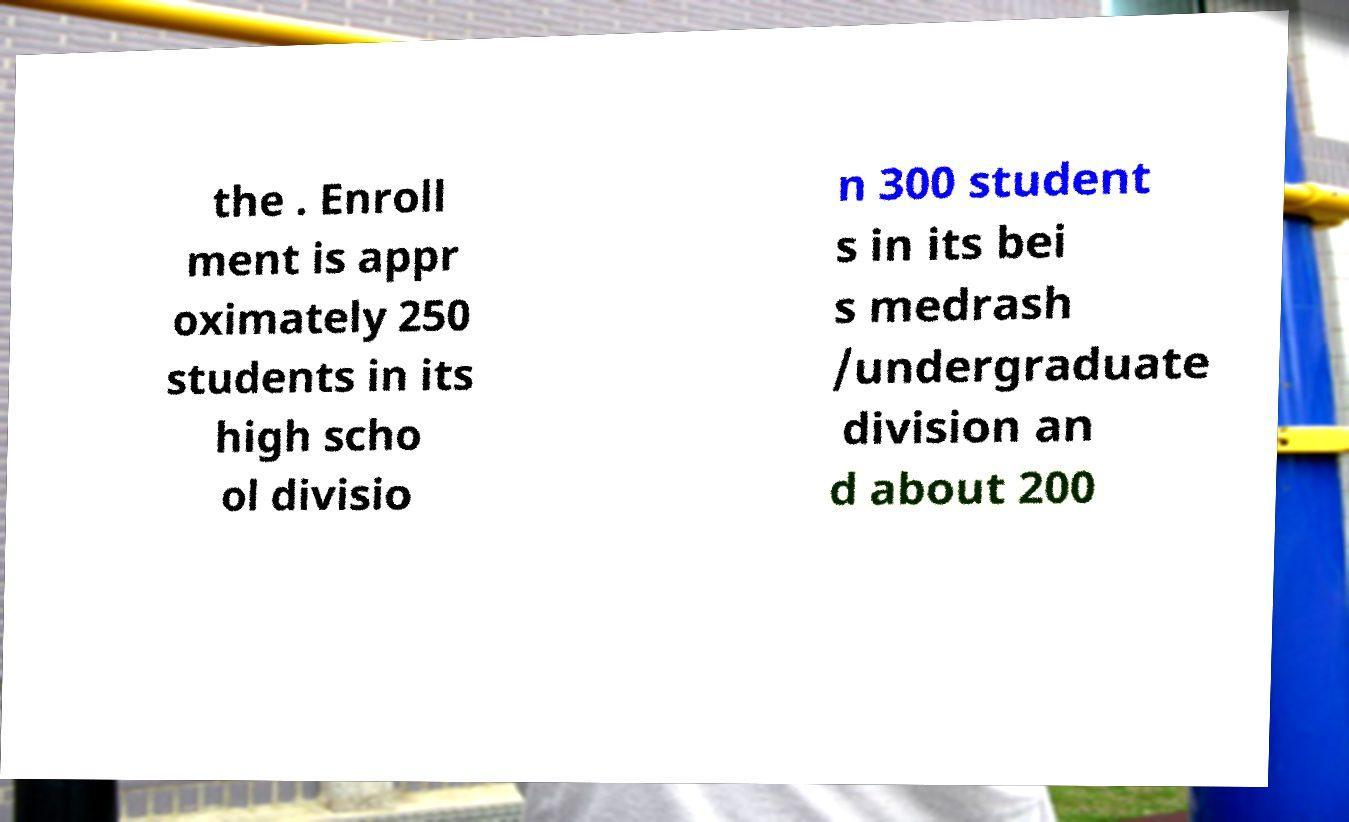Please read and relay the text visible in this image. What does it say? the . Enroll ment is appr oximately 250 students in its high scho ol divisio n 300 student s in its bei s medrash /undergraduate division an d about 200 